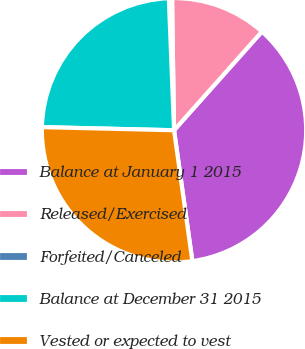Convert chart to OTSL. <chart><loc_0><loc_0><loc_500><loc_500><pie_chart><fcel>Balance at January 1 2015<fcel>Released/Exercised<fcel>Forfeited/Canceled<fcel>Balance at December 31 2015<fcel>Vested or expected to vest<nl><fcel>36.21%<fcel>11.82%<fcel>0.39%<fcel>24.0%<fcel>27.59%<nl></chart> 